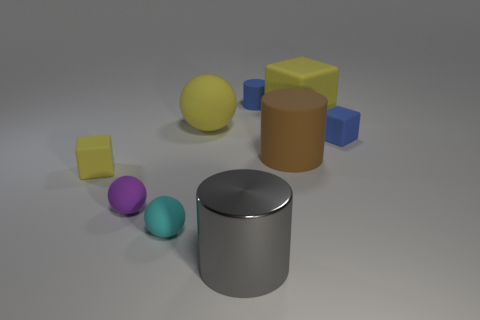Is there a gray metal cylinder that has the same size as the brown cylinder?
Offer a terse response. Yes. There is a small blue object that is left of the tiny matte block that is to the right of the big gray metal thing; what is its material?
Ensure brevity in your answer.  Rubber. How many big cubes have the same color as the large matte ball?
Make the answer very short. 1. What is the shape of the tiny cyan thing that is made of the same material as the small yellow block?
Ensure brevity in your answer.  Sphere. What size is the matte block on the left side of the cyan thing?
Your response must be concise. Small. Are there the same number of big gray objects that are to the right of the gray cylinder and yellow matte balls to the right of the big yellow matte sphere?
Ensure brevity in your answer.  Yes. What is the color of the small rubber cube to the left of the tiny matte cube right of the yellow block in front of the tiny blue block?
Give a very brief answer. Yellow. What number of things are behind the big matte cylinder and on the left side of the small blue rubber cube?
Ensure brevity in your answer.  3. There is a tiny cube to the right of the tiny yellow cube; is it the same color as the large rubber thing to the left of the gray metallic thing?
Ensure brevity in your answer.  No. Is there anything else that is the same material as the tiny cylinder?
Ensure brevity in your answer.  Yes. 